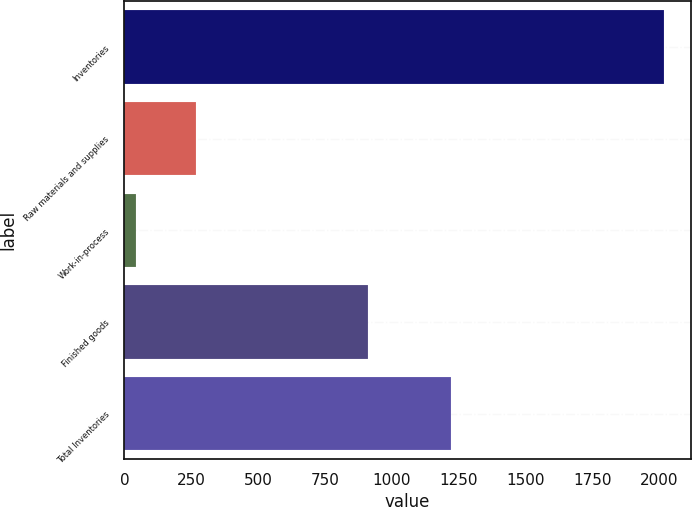Convert chart. <chart><loc_0><loc_0><loc_500><loc_500><bar_chart><fcel>Inventories<fcel>Raw materials and supplies<fcel>Work-in-process<fcel>Finished goods<fcel>Total Inventories<nl><fcel>2017<fcel>267<fcel>42<fcel>912<fcel>1221<nl></chart> 